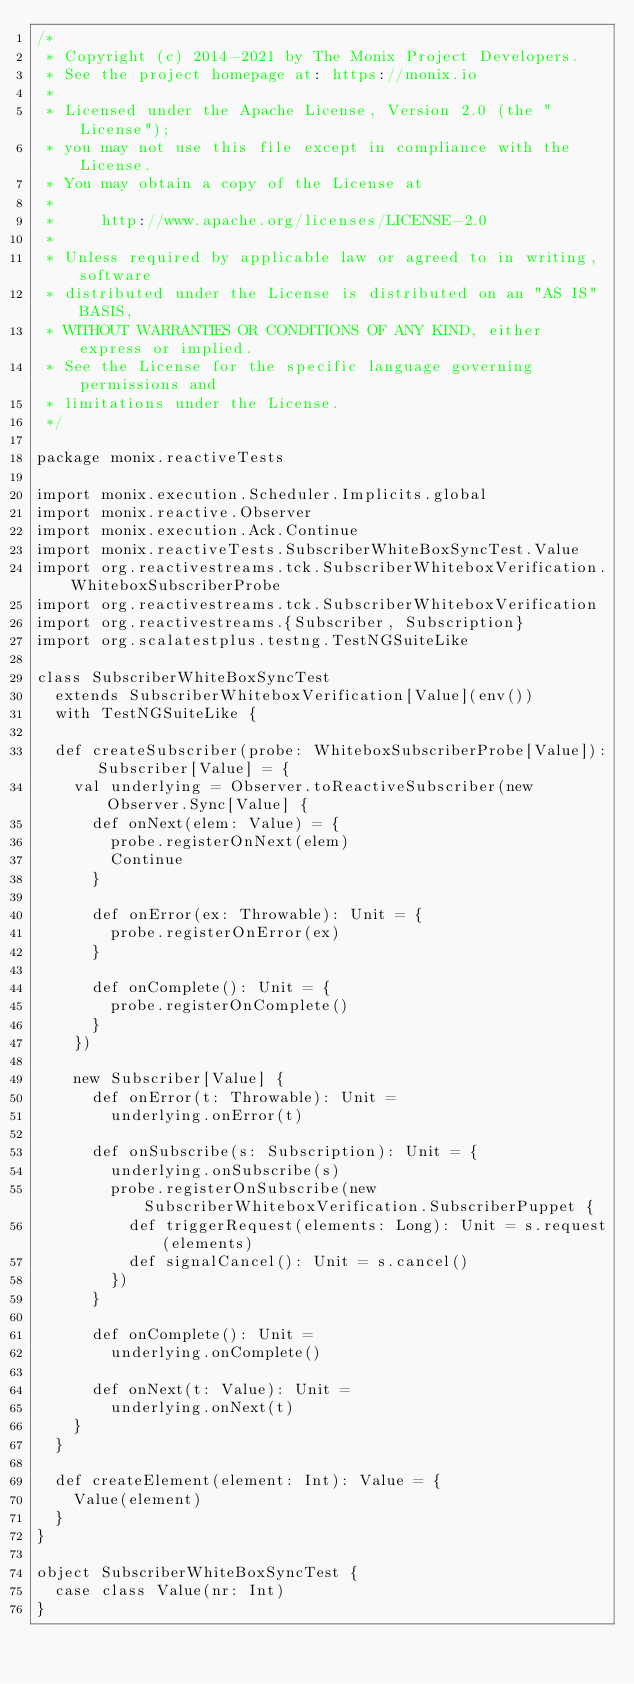Convert code to text. <code><loc_0><loc_0><loc_500><loc_500><_Scala_>/*
 * Copyright (c) 2014-2021 by The Monix Project Developers.
 * See the project homepage at: https://monix.io
 *
 * Licensed under the Apache License, Version 2.0 (the "License");
 * you may not use this file except in compliance with the License.
 * You may obtain a copy of the License at
 *
 *     http://www.apache.org/licenses/LICENSE-2.0
 *
 * Unless required by applicable law or agreed to in writing, software
 * distributed under the License is distributed on an "AS IS" BASIS,
 * WITHOUT WARRANTIES OR CONDITIONS OF ANY KIND, either express or implied.
 * See the License for the specific language governing permissions and
 * limitations under the License.
 */

package monix.reactiveTests

import monix.execution.Scheduler.Implicits.global
import monix.reactive.Observer
import monix.execution.Ack.Continue
import monix.reactiveTests.SubscriberWhiteBoxSyncTest.Value
import org.reactivestreams.tck.SubscriberWhiteboxVerification.WhiteboxSubscriberProbe
import org.reactivestreams.tck.SubscriberWhiteboxVerification
import org.reactivestreams.{Subscriber, Subscription}
import org.scalatestplus.testng.TestNGSuiteLike

class SubscriberWhiteBoxSyncTest
  extends SubscriberWhiteboxVerification[Value](env())
  with TestNGSuiteLike {

  def createSubscriber(probe: WhiteboxSubscriberProbe[Value]): Subscriber[Value] = {
    val underlying = Observer.toReactiveSubscriber(new Observer.Sync[Value] {
      def onNext(elem: Value) = {
        probe.registerOnNext(elem)
        Continue
      }

      def onError(ex: Throwable): Unit = {
        probe.registerOnError(ex)
      }

      def onComplete(): Unit = {
        probe.registerOnComplete()
      }
    })

    new Subscriber[Value] {
      def onError(t: Throwable): Unit =
        underlying.onError(t)

      def onSubscribe(s: Subscription): Unit = {
        underlying.onSubscribe(s)
        probe.registerOnSubscribe(new SubscriberWhiteboxVerification.SubscriberPuppet {
          def triggerRequest(elements: Long): Unit = s.request(elements)
          def signalCancel(): Unit = s.cancel()
        })
      }

      def onComplete(): Unit =
        underlying.onComplete()

      def onNext(t: Value): Unit =
        underlying.onNext(t)
    }
  }

  def createElement(element: Int): Value = {
    Value(element)
  }
}

object SubscriberWhiteBoxSyncTest {
  case class Value(nr: Int)
}
</code> 